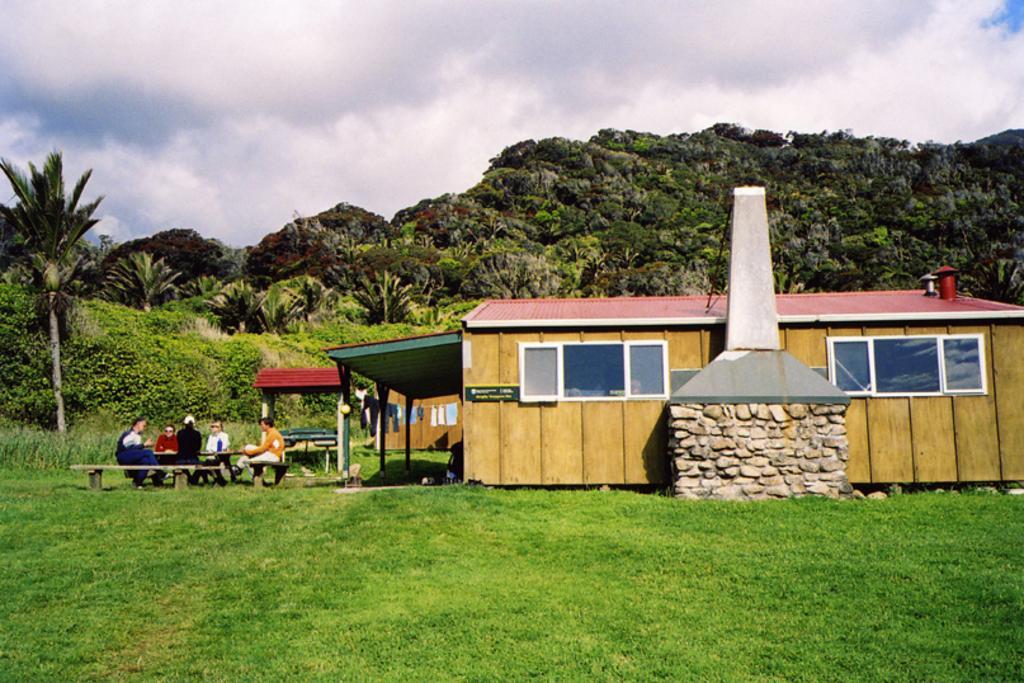Could you give a brief overview of what you see in this image? In this image there is the sky, there are clouds in the sky, there are clouds in the sky, there are trees, there is a house truncated towards the right of the image, there is a sculptor, there are person sitting on the bench, there is the grass, there are clothes, there is a board on the house, there is text on the board, there are windows, there are plants truncated towards the left of the image. 